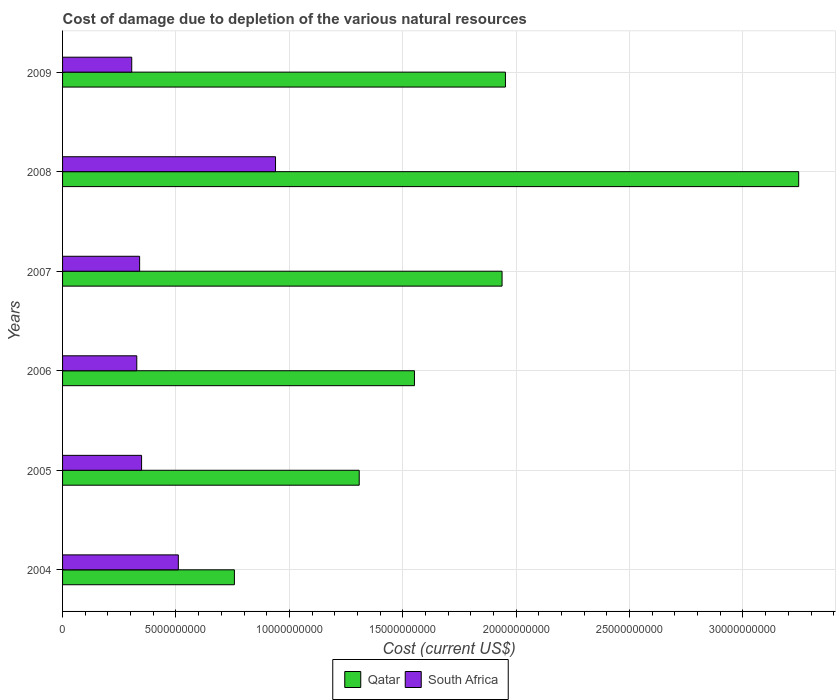How many different coloured bars are there?
Your answer should be compact. 2. Are the number of bars per tick equal to the number of legend labels?
Offer a terse response. Yes. How many bars are there on the 1st tick from the top?
Provide a short and direct response. 2. What is the cost of damage caused due to the depletion of various natural resources in South Africa in 2007?
Offer a very short reply. 3.40e+09. Across all years, what is the maximum cost of damage caused due to the depletion of various natural resources in Qatar?
Your response must be concise. 3.25e+1. Across all years, what is the minimum cost of damage caused due to the depletion of various natural resources in Qatar?
Provide a short and direct response. 7.58e+09. In which year was the cost of damage caused due to the depletion of various natural resources in South Africa maximum?
Your answer should be very brief. 2008. What is the total cost of damage caused due to the depletion of various natural resources in Qatar in the graph?
Give a very brief answer. 1.08e+11. What is the difference between the cost of damage caused due to the depletion of various natural resources in Qatar in 2005 and that in 2008?
Your answer should be very brief. -1.94e+1. What is the difference between the cost of damage caused due to the depletion of various natural resources in Qatar in 2006 and the cost of damage caused due to the depletion of various natural resources in South Africa in 2007?
Offer a terse response. 1.21e+1. What is the average cost of damage caused due to the depletion of various natural resources in Qatar per year?
Provide a succinct answer. 1.79e+1. In the year 2009, what is the difference between the cost of damage caused due to the depletion of various natural resources in Qatar and cost of damage caused due to the depletion of various natural resources in South Africa?
Your response must be concise. 1.65e+1. What is the ratio of the cost of damage caused due to the depletion of various natural resources in South Africa in 2004 to that in 2009?
Give a very brief answer. 1.67. Is the difference between the cost of damage caused due to the depletion of various natural resources in Qatar in 2005 and 2008 greater than the difference between the cost of damage caused due to the depletion of various natural resources in South Africa in 2005 and 2008?
Your response must be concise. No. What is the difference between the highest and the second highest cost of damage caused due to the depletion of various natural resources in Qatar?
Offer a terse response. 1.29e+1. What is the difference between the highest and the lowest cost of damage caused due to the depletion of various natural resources in South Africa?
Give a very brief answer. 6.34e+09. Is the sum of the cost of damage caused due to the depletion of various natural resources in Qatar in 2005 and 2009 greater than the maximum cost of damage caused due to the depletion of various natural resources in South Africa across all years?
Keep it short and to the point. Yes. What does the 2nd bar from the top in 2004 represents?
Offer a very short reply. Qatar. What does the 2nd bar from the bottom in 2007 represents?
Offer a terse response. South Africa. How many bars are there?
Make the answer very short. 12. Are the values on the major ticks of X-axis written in scientific E-notation?
Offer a very short reply. No. Does the graph contain grids?
Offer a very short reply. Yes. Where does the legend appear in the graph?
Provide a short and direct response. Bottom center. How many legend labels are there?
Ensure brevity in your answer.  2. How are the legend labels stacked?
Offer a terse response. Horizontal. What is the title of the graph?
Your answer should be very brief. Cost of damage due to depletion of the various natural resources. What is the label or title of the X-axis?
Your response must be concise. Cost (current US$). What is the label or title of the Y-axis?
Ensure brevity in your answer.  Years. What is the Cost (current US$) in Qatar in 2004?
Make the answer very short. 7.58e+09. What is the Cost (current US$) of South Africa in 2004?
Offer a terse response. 5.10e+09. What is the Cost (current US$) in Qatar in 2005?
Your answer should be compact. 1.31e+1. What is the Cost (current US$) of South Africa in 2005?
Your answer should be compact. 3.48e+09. What is the Cost (current US$) of Qatar in 2006?
Keep it short and to the point. 1.55e+1. What is the Cost (current US$) in South Africa in 2006?
Ensure brevity in your answer.  3.27e+09. What is the Cost (current US$) in Qatar in 2007?
Provide a succinct answer. 1.94e+1. What is the Cost (current US$) of South Africa in 2007?
Provide a succinct answer. 3.40e+09. What is the Cost (current US$) of Qatar in 2008?
Offer a very short reply. 3.25e+1. What is the Cost (current US$) of South Africa in 2008?
Provide a short and direct response. 9.39e+09. What is the Cost (current US$) of Qatar in 2009?
Offer a very short reply. 1.95e+1. What is the Cost (current US$) of South Africa in 2009?
Provide a succinct answer. 3.05e+09. Across all years, what is the maximum Cost (current US$) in Qatar?
Give a very brief answer. 3.25e+1. Across all years, what is the maximum Cost (current US$) in South Africa?
Make the answer very short. 9.39e+09. Across all years, what is the minimum Cost (current US$) of Qatar?
Make the answer very short. 7.58e+09. Across all years, what is the minimum Cost (current US$) of South Africa?
Provide a succinct answer. 3.05e+09. What is the total Cost (current US$) of Qatar in the graph?
Provide a short and direct response. 1.08e+11. What is the total Cost (current US$) of South Africa in the graph?
Make the answer very short. 2.77e+1. What is the difference between the Cost (current US$) of Qatar in 2004 and that in 2005?
Your answer should be compact. -5.50e+09. What is the difference between the Cost (current US$) of South Africa in 2004 and that in 2005?
Keep it short and to the point. 1.62e+09. What is the difference between the Cost (current US$) in Qatar in 2004 and that in 2006?
Offer a terse response. -7.94e+09. What is the difference between the Cost (current US$) in South Africa in 2004 and that in 2006?
Give a very brief answer. 1.83e+09. What is the difference between the Cost (current US$) of Qatar in 2004 and that in 2007?
Ensure brevity in your answer.  -1.18e+1. What is the difference between the Cost (current US$) of South Africa in 2004 and that in 2007?
Your response must be concise. 1.71e+09. What is the difference between the Cost (current US$) in Qatar in 2004 and that in 2008?
Give a very brief answer. -2.49e+1. What is the difference between the Cost (current US$) of South Africa in 2004 and that in 2008?
Provide a short and direct response. -4.29e+09. What is the difference between the Cost (current US$) of Qatar in 2004 and that in 2009?
Provide a short and direct response. -1.19e+1. What is the difference between the Cost (current US$) of South Africa in 2004 and that in 2009?
Your response must be concise. 2.05e+09. What is the difference between the Cost (current US$) in Qatar in 2005 and that in 2006?
Keep it short and to the point. -2.44e+09. What is the difference between the Cost (current US$) in South Africa in 2005 and that in 2006?
Make the answer very short. 2.12e+08. What is the difference between the Cost (current US$) in Qatar in 2005 and that in 2007?
Give a very brief answer. -6.30e+09. What is the difference between the Cost (current US$) of South Africa in 2005 and that in 2007?
Provide a succinct answer. 8.63e+07. What is the difference between the Cost (current US$) of Qatar in 2005 and that in 2008?
Provide a short and direct response. -1.94e+1. What is the difference between the Cost (current US$) of South Africa in 2005 and that in 2008?
Provide a succinct answer. -5.91e+09. What is the difference between the Cost (current US$) in Qatar in 2005 and that in 2009?
Provide a succinct answer. -6.45e+09. What is the difference between the Cost (current US$) of South Africa in 2005 and that in 2009?
Offer a very short reply. 4.34e+08. What is the difference between the Cost (current US$) in Qatar in 2006 and that in 2007?
Your answer should be very brief. -3.86e+09. What is the difference between the Cost (current US$) of South Africa in 2006 and that in 2007?
Provide a short and direct response. -1.25e+08. What is the difference between the Cost (current US$) in Qatar in 2006 and that in 2008?
Your answer should be very brief. -1.69e+1. What is the difference between the Cost (current US$) in South Africa in 2006 and that in 2008?
Give a very brief answer. -6.12e+09. What is the difference between the Cost (current US$) of Qatar in 2006 and that in 2009?
Ensure brevity in your answer.  -4.01e+09. What is the difference between the Cost (current US$) of South Africa in 2006 and that in 2009?
Ensure brevity in your answer.  2.22e+08. What is the difference between the Cost (current US$) of Qatar in 2007 and that in 2008?
Your response must be concise. -1.31e+1. What is the difference between the Cost (current US$) in South Africa in 2007 and that in 2008?
Provide a succinct answer. -5.99e+09. What is the difference between the Cost (current US$) in Qatar in 2007 and that in 2009?
Keep it short and to the point. -1.49e+08. What is the difference between the Cost (current US$) of South Africa in 2007 and that in 2009?
Your answer should be compact. 3.48e+08. What is the difference between the Cost (current US$) in Qatar in 2008 and that in 2009?
Offer a terse response. 1.29e+1. What is the difference between the Cost (current US$) in South Africa in 2008 and that in 2009?
Make the answer very short. 6.34e+09. What is the difference between the Cost (current US$) in Qatar in 2004 and the Cost (current US$) in South Africa in 2005?
Provide a succinct answer. 4.09e+09. What is the difference between the Cost (current US$) of Qatar in 2004 and the Cost (current US$) of South Africa in 2006?
Provide a short and direct response. 4.30e+09. What is the difference between the Cost (current US$) of Qatar in 2004 and the Cost (current US$) of South Africa in 2007?
Give a very brief answer. 4.18e+09. What is the difference between the Cost (current US$) of Qatar in 2004 and the Cost (current US$) of South Africa in 2008?
Your answer should be very brief. -1.81e+09. What is the difference between the Cost (current US$) in Qatar in 2004 and the Cost (current US$) in South Africa in 2009?
Your answer should be compact. 4.53e+09. What is the difference between the Cost (current US$) of Qatar in 2005 and the Cost (current US$) of South Africa in 2006?
Offer a terse response. 9.81e+09. What is the difference between the Cost (current US$) in Qatar in 2005 and the Cost (current US$) in South Africa in 2007?
Give a very brief answer. 9.68e+09. What is the difference between the Cost (current US$) of Qatar in 2005 and the Cost (current US$) of South Africa in 2008?
Your answer should be compact. 3.69e+09. What is the difference between the Cost (current US$) of Qatar in 2005 and the Cost (current US$) of South Africa in 2009?
Offer a terse response. 1.00e+1. What is the difference between the Cost (current US$) of Qatar in 2006 and the Cost (current US$) of South Africa in 2007?
Your answer should be compact. 1.21e+1. What is the difference between the Cost (current US$) in Qatar in 2006 and the Cost (current US$) in South Africa in 2008?
Your answer should be very brief. 6.13e+09. What is the difference between the Cost (current US$) of Qatar in 2006 and the Cost (current US$) of South Africa in 2009?
Provide a succinct answer. 1.25e+1. What is the difference between the Cost (current US$) in Qatar in 2007 and the Cost (current US$) in South Africa in 2008?
Your answer should be compact. 9.99e+09. What is the difference between the Cost (current US$) of Qatar in 2007 and the Cost (current US$) of South Africa in 2009?
Your answer should be compact. 1.63e+1. What is the difference between the Cost (current US$) in Qatar in 2008 and the Cost (current US$) in South Africa in 2009?
Your response must be concise. 2.94e+1. What is the average Cost (current US$) of Qatar per year?
Provide a short and direct response. 1.79e+1. What is the average Cost (current US$) in South Africa per year?
Give a very brief answer. 4.62e+09. In the year 2004, what is the difference between the Cost (current US$) of Qatar and Cost (current US$) of South Africa?
Offer a very short reply. 2.47e+09. In the year 2005, what is the difference between the Cost (current US$) of Qatar and Cost (current US$) of South Africa?
Provide a short and direct response. 9.60e+09. In the year 2006, what is the difference between the Cost (current US$) in Qatar and Cost (current US$) in South Africa?
Provide a succinct answer. 1.22e+1. In the year 2007, what is the difference between the Cost (current US$) in Qatar and Cost (current US$) in South Africa?
Your answer should be very brief. 1.60e+1. In the year 2008, what is the difference between the Cost (current US$) in Qatar and Cost (current US$) in South Africa?
Offer a terse response. 2.31e+1. In the year 2009, what is the difference between the Cost (current US$) in Qatar and Cost (current US$) in South Africa?
Make the answer very short. 1.65e+1. What is the ratio of the Cost (current US$) of Qatar in 2004 to that in 2005?
Give a very brief answer. 0.58. What is the ratio of the Cost (current US$) of South Africa in 2004 to that in 2005?
Offer a very short reply. 1.46. What is the ratio of the Cost (current US$) in Qatar in 2004 to that in 2006?
Your answer should be very brief. 0.49. What is the ratio of the Cost (current US$) of South Africa in 2004 to that in 2006?
Give a very brief answer. 1.56. What is the ratio of the Cost (current US$) of Qatar in 2004 to that in 2007?
Your answer should be very brief. 0.39. What is the ratio of the Cost (current US$) of South Africa in 2004 to that in 2007?
Offer a terse response. 1.5. What is the ratio of the Cost (current US$) in Qatar in 2004 to that in 2008?
Your answer should be very brief. 0.23. What is the ratio of the Cost (current US$) in South Africa in 2004 to that in 2008?
Give a very brief answer. 0.54. What is the ratio of the Cost (current US$) in Qatar in 2004 to that in 2009?
Offer a terse response. 0.39. What is the ratio of the Cost (current US$) of South Africa in 2004 to that in 2009?
Offer a very short reply. 1.67. What is the ratio of the Cost (current US$) in Qatar in 2005 to that in 2006?
Give a very brief answer. 0.84. What is the ratio of the Cost (current US$) of South Africa in 2005 to that in 2006?
Your answer should be compact. 1.06. What is the ratio of the Cost (current US$) in Qatar in 2005 to that in 2007?
Keep it short and to the point. 0.68. What is the ratio of the Cost (current US$) of South Africa in 2005 to that in 2007?
Make the answer very short. 1.03. What is the ratio of the Cost (current US$) in Qatar in 2005 to that in 2008?
Provide a short and direct response. 0.4. What is the ratio of the Cost (current US$) in South Africa in 2005 to that in 2008?
Keep it short and to the point. 0.37. What is the ratio of the Cost (current US$) in Qatar in 2005 to that in 2009?
Offer a very short reply. 0.67. What is the ratio of the Cost (current US$) in South Africa in 2005 to that in 2009?
Offer a terse response. 1.14. What is the ratio of the Cost (current US$) of Qatar in 2006 to that in 2007?
Ensure brevity in your answer.  0.8. What is the ratio of the Cost (current US$) of South Africa in 2006 to that in 2007?
Provide a succinct answer. 0.96. What is the ratio of the Cost (current US$) of Qatar in 2006 to that in 2008?
Your answer should be compact. 0.48. What is the ratio of the Cost (current US$) in South Africa in 2006 to that in 2008?
Offer a very short reply. 0.35. What is the ratio of the Cost (current US$) in Qatar in 2006 to that in 2009?
Provide a succinct answer. 0.79. What is the ratio of the Cost (current US$) in South Africa in 2006 to that in 2009?
Offer a very short reply. 1.07. What is the ratio of the Cost (current US$) in Qatar in 2007 to that in 2008?
Offer a terse response. 0.6. What is the ratio of the Cost (current US$) in South Africa in 2007 to that in 2008?
Ensure brevity in your answer.  0.36. What is the ratio of the Cost (current US$) of South Africa in 2007 to that in 2009?
Your answer should be very brief. 1.11. What is the ratio of the Cost (current US$) in Qatar in 2008 to that in 2009?
Give a very brief answer. 1.66. What is the ratio of the Cost (current US$) of South Africa in 2008 to that in 2009?
Offer a terse response. 3.08. What is the difference between the highest and the second highest Cost (current US$) of Qatar?
Offer a very short reply. 1.29e+1. What is the difference between the highest and the second highest Cost (current US$) in South Africa?
Your response must be concise. 4.29e+09. What is the difference between the highest and the lowest Cost (current US$) in Qatar?
Offer a terse response. 2.49e+1. What is the difference between the highest and the lowest Cost (current US$) in South Africa?
Your answer should be compact. 6.34e+09. 